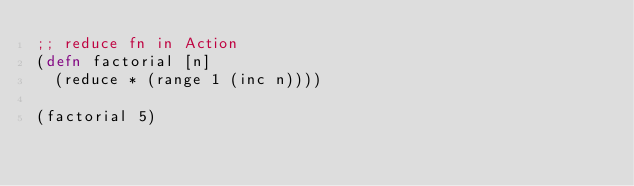Convert code to text. <code><loc_0><loc_0><loc_500><loc_500><_Clojure_>;; reduce fn in Action
(defn factorial [n]
  (reduce * (range 1 (inc n))))

(factorial 5) 
</code> 